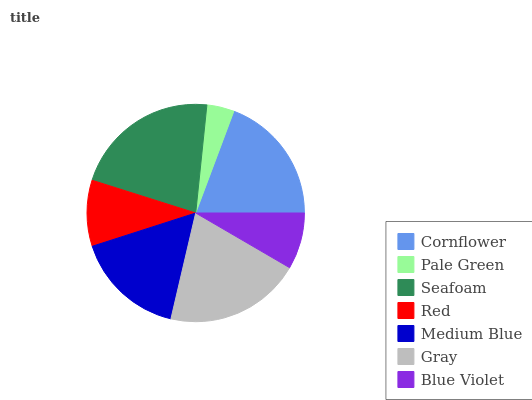Is Pale Green the minimum?
Answer yes or no. Yes. Is Seafoam the maximum?
Answer yes or no. Yes. Is Seafoam the minimum?
Answer yes or no. No. Is Pale Green the maximum?
Answer yes or no. No. Is Seafoam greater than Pale Green?
Answer yes or no. Yes. Is Pale Green less than Seafoam?
Answer yes or no. Yes. Is Pale Green greater than Seafoam?
Answer yes or no. No. Is Seafoam less than Pale Green?
Answer yes or no. No. Is Medium Blue the high median?
Answer yes or no. Yes. Is Medium Blue the low median?
Answer yes or no. Yes. Is Seafoam the high median?
Answer yes or no. No. Is Pale Green the low median?
Answer yes or no. No. 